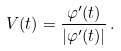Convert formula to latex. <formula><loc_0><loc_0><loc_500><loc_500>V ( t ) = \frac { \varphi ^ { \prime } ( t ) } { | \varphi ^ { \prime } ( t ) | } \, .</formula> 